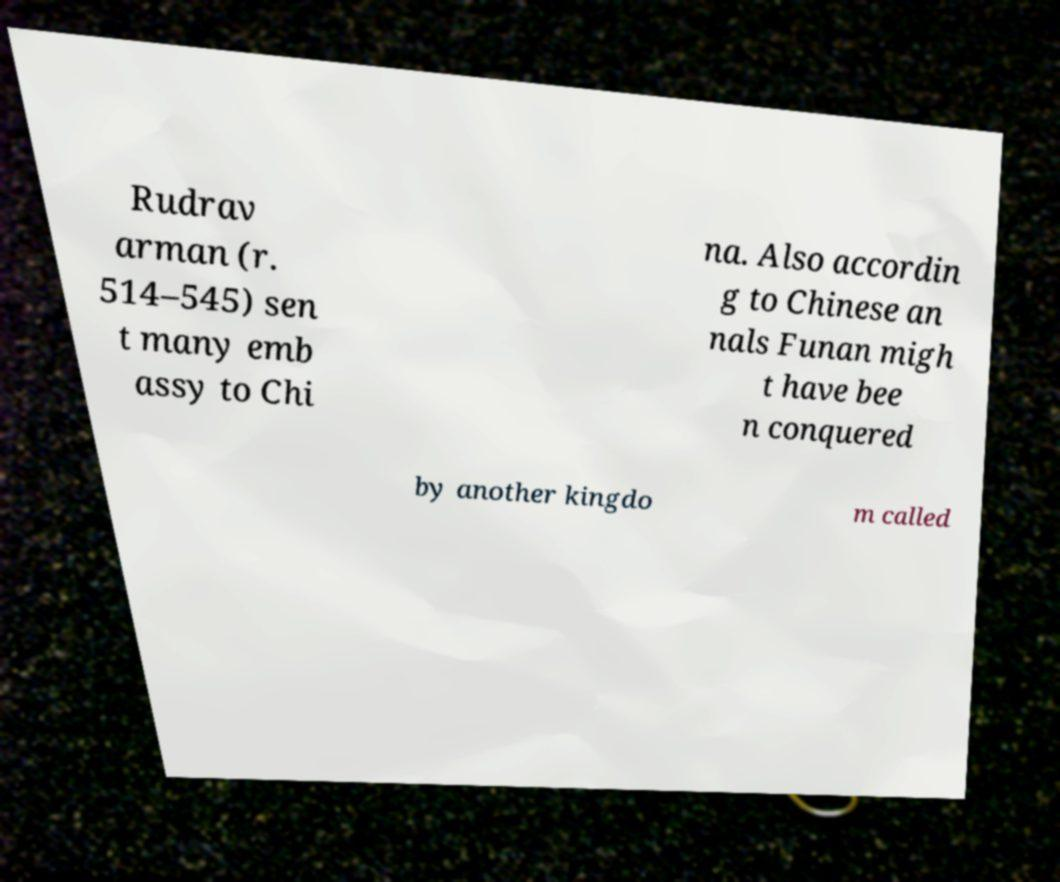Please identify and transcribe the text found in this image. Rudrav arman (r. 514–545) sen t many emb assy to Chi na. Also accordin g to Chinese an nals Funan migh t have bee n conquered by another kingdo m called 